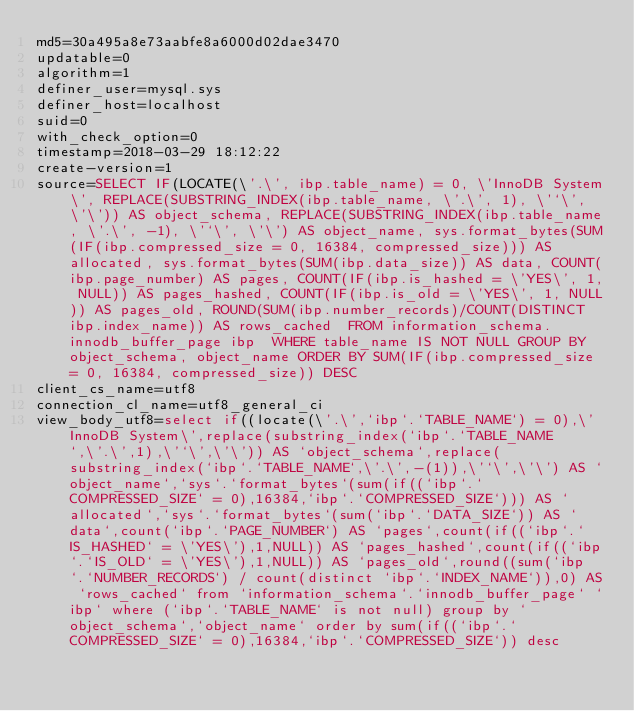Convert code to text. <code><loc_0><loc_0><loc_500><loc_500><_VisualBasic_>md5=30a495a8e73aabfe8a6000d02dae3470
updatable=0
algorithm=1
definer_user=mysql.sys
definer_host=localhost
suid=0
with_check_option=0
timestamp=2018-03-29 18:12:22
create-version=1
source=SELECT IF(LOCATE(\'.\', ibp.table_name) = 0, \'InnoDB System\', REPLACE(SUBSTRING_INDEX(ibp.table_name, \'.\', 1), \'`\', \'\')) AS object_schema, REPLACE(SUBSTRING_INDEX(ibp.table_name, \'.\', -1), \'`\', \'\') AS object_name, sys.format_bytes(SUM(IF(ibp.compressed_size = 0, 16384, compressed_size))) AS allocated, sys.format_bytes(SUM(ibp.data_size)) AS data, COUNT(ibp.page_number) AS pages, COUNT(IF(ibp.is_hashed = \'YES\', 1, NULL)) AS pages_hashed, COUNT(IF(ibp.is_old = \'YES\', 1, NULL)) AS pages_old, ROUND(SUM(ibp.number_records)/COUNT(DISTINCT ibp.index_name)) AS rows_cached  FROM information_schema.innodb_buffer_page ibp  WHERE table_name IS NOT NULL GROUP BY object_schema, object_name ORDER BY SUM(IF(ibp.compressed_size = 0, 16384, compressed_size)) DESC
client_cs_name=utf8
connection_cl_name=utf8_general_ci
view_body_utf8=select if((locate(\'.\',`ibp`.`TABLE_NAME`) = 0),\'InnoDB System\',replace(substring_index(`ibp`.`TABLE_NAME`,\'.\',1),\'`\',\'\')) AS `object_schema`,replace(substring_index(`ibp`.`TABLE_NAME`,\'.\',-(1)),\'`\',\'\') AS `object_name`,`sys`.`format_bytes`(sum(if((`ibp`.`COMPRESSED_SIZE` = 0),16384,`ibp`.`COMPRESSED_SIZE`))) AS `allocated`,`sys`.`format_bytes`(sum(`ibp`.`DATA_SIZE`)) AS `data`,count(`ibp`.`PAGE_NUMBER`) AS `pages`,count(if((`ibp`.`IS_HASHED` = \'YES\'),1,NULL)) AS `pages_hashed`,count(if((`ibp`.`IS_OLD` = \'YES\'),1,NULL)) AS `pages_old`,round((sum(`ibp`.`NUMBER_RECORDS`) / count(distinct `ibp`.`INDEX_NAME`)),0) AS `rows_cached` from `information_schema`.`innodb_buffer_page` `ibp` where (`ibp`.`TABLE_NAME` is not null) group by `object_schema`,`object_name` order by sum(if((`ibp`.`COMPRESSED_SIZE` = 0),16384,`ibp`.`COMPRESSED_SIZE`)) desc
</code> 